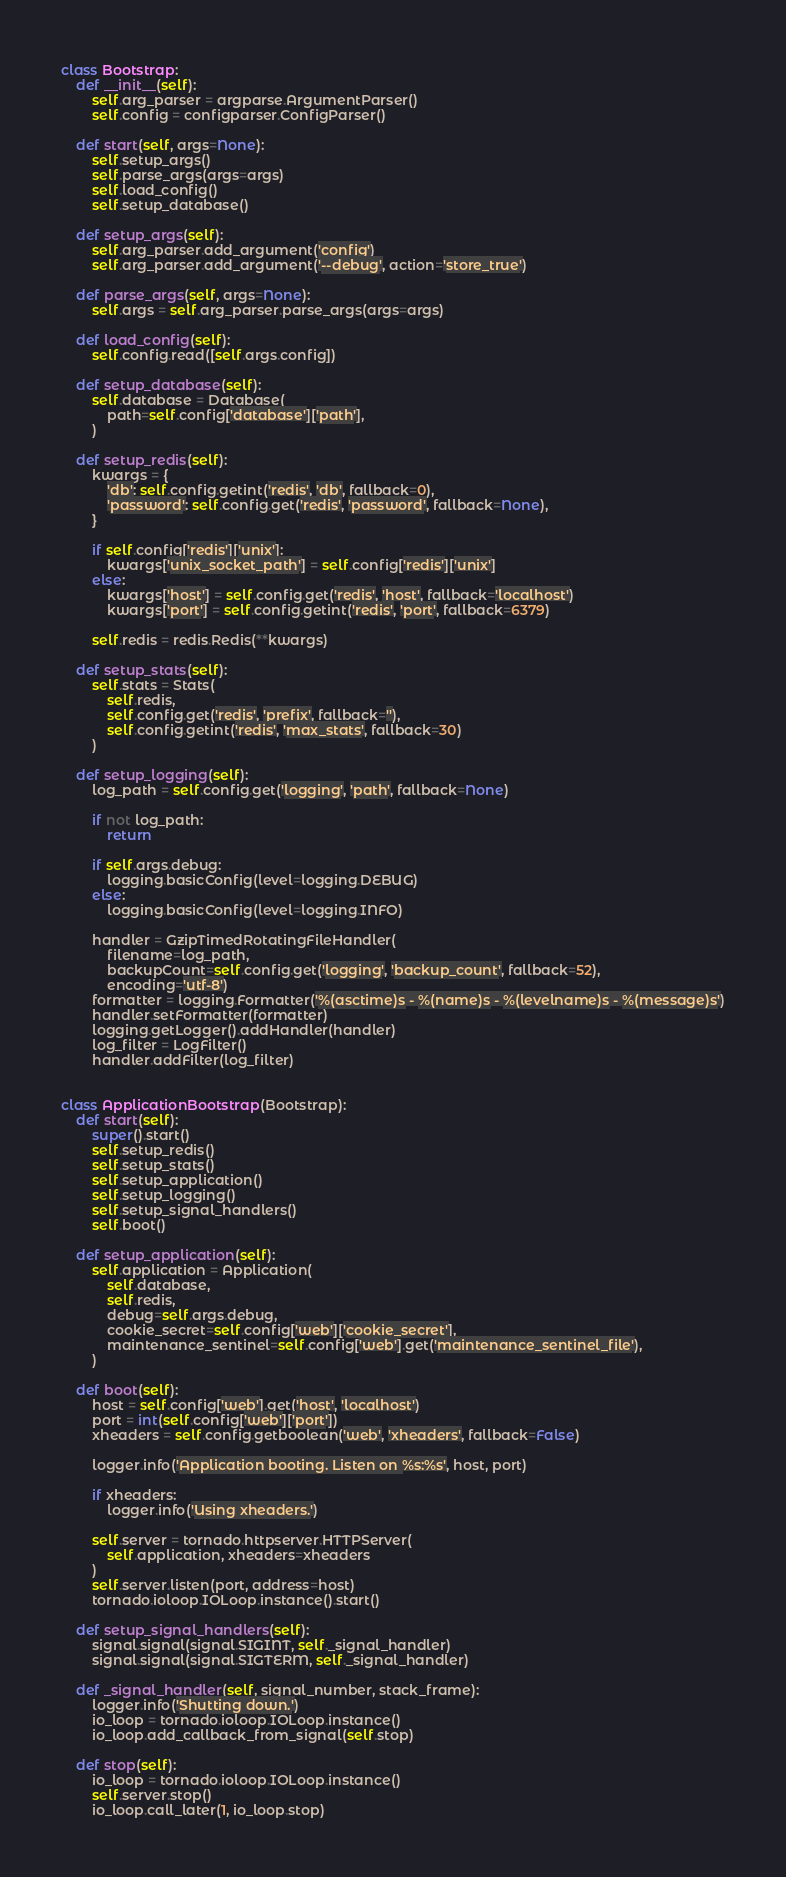<code> <loc_0><loc_0><loc_500><loc_500><_Python_>
class Bootstrap:
    def __init__(self):
        self.arg_parser = argparse.ArgumentParser()
        self.config = configparser.ConfigParser()

    def start(self, args=None):
        self.setup_args()
        self.parse_args(args=args)
        self.load_config()
        self.setup_database()

    def setup_args(self):
        self.arg_parser.add_argument('config')
        self.arg_parser.add_argument('--debug', action='store_true')

    def parse_args(self, args=None):
        self.args = self.arg_parser.parse_args(args=args)

    def load_config(self):
        self.config.read([self.args.config])

    def setup_database(self):
        self.database = Database(
            path=self.config['database']['path'],
        )

    def setup_redis(self):
        kwargs = {
            'db': self.config.getint('redis', 'db', fallback=0),
            'password': self.config.get('redis', 'password', fallback=None),
        }

        if self.config['redis']['unix']:
            kwargs['unix_socket_path'] = self.config['redis']['unix']
        else:
            kwargs['host'] = self.config.get('redis', 'host', fallback='localhost')
            kwargs['port'] = self.config.getint('redis', 'port', fallback=6379)

        self.redis = redis.Redis(**kwargs)

    def setup_stats(self):
        self.stats = Stats(
            self.redis,
            self.config.get('redis', 'prefix', fallback=''),
            self.config.getint('redis', 'max_stats', fallback=30)
        )

    def setup_logging(self):
        log_path = self.config.get('logging', 'path', fallback=None)

        if not log_path:
            return

        if self.args.debug:
            logging.basicConfig(level=logging.DEBUG)
        else:
            logging.basicConfig(level=logging.INFO)

        handler = GzipTimedRotatingFileHandler(
            filename=log_path,
            backupCount=self.config.get('logging', 'backup_count', fallback=52),
            encoding='utf-8')
        formatter = logging.Formatter('%(asctime)s - %(name)s - %(levelname)s - %(message)s')
        handler.setFormatter(formatter)
        logging.getLogger().addHandler(handler)
        log_filter = LogFilter()
        handler.addFilter(log_filter)


class ApplicationBootstrap(Bootstrap):
    def start(self):
        super().start()
        self.setup_redis()
        self.setup_stats()
        self.setup_application()
        self.setup_logging()
        self.setup_signal_handlers()
        self.boot()

    def setup_application(self):
        self.application = Application(
            self.database,
            self.redis,
            debug=self.args.debug,
            cookie_secret=self.config['web']['cookie_secret'],
            maintenance_sentinel=self.config['web'].get('maintenance_sentinel_file'),
        )

    def boot(self):
        host = self.config['web'].get('host', 'localhost')
        port = int(self.config['web']['port'])
        xheaders = self.config.getboolean('web', 'xheaders', fallback=False)

        logger.info('Application booting. Listen on %s:%s', host, port)

        if xheaders:
            logger.info('Using xheaders.')

        self.server = tornado.httpserver.HTTPServer(
            self.application, xheaders=xheaders
        )
        self.server.listen(port, address=host)
        tornado.ioloop.IOLoop.instance().start()

    def setup_signal_handlers(self):
        signal.signal(signal.SIGINT, self._signal_handler)
        signal.signal(signal.SIGTERM, self._signal_handler)

    def _signal_handler(self, signal_number, stack_frame):
        logger.info('Shutting down.')
        io_loop = tornado.ioloop.IOLoop.instance()
        io_loop.add_callback_from_signal(self.stop)

    def stop(self):
        io_loop = tornado.ioloop.IOLoop.instance()
        self.server.stop()
        io_loop.call_later(1, io_loop.stop)
</code> 